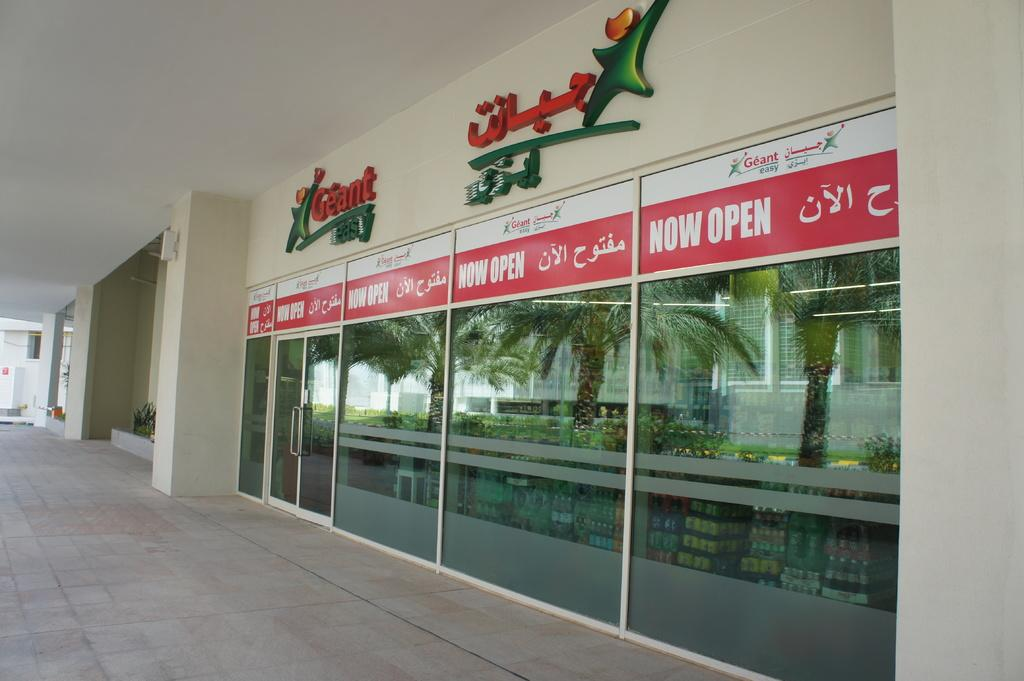What type of door is visible in the image? There is a glass door in the image. What other architectural feature can be seen in the image? There is a glass wall in the image. What can be seen in the mirror reflection? Trees are visible in the mirror reflection. What type of fuel is being used by the club in the image? There is no club or fuel present in the image. What act is being performed in the image? There is no act or performance taking place in the image. 